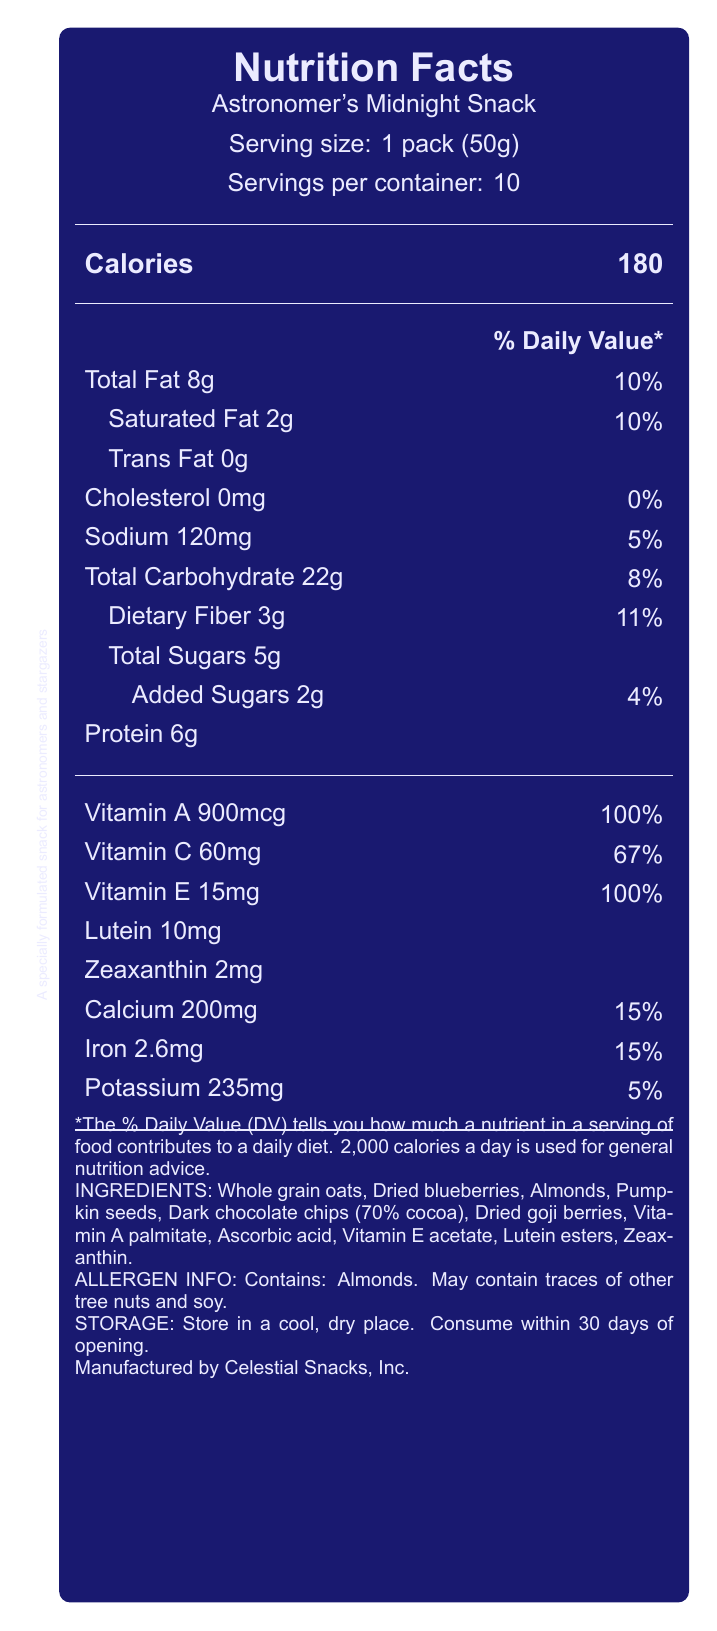What is the serving size of Astronomer's Midnight Snack? The label states that the serving size is "1 pack (50g)".
Answer: 1 pack (50g) How many calories are there in one serving? The label indicates that one serving contains 180 calories.
Answer: 180 What is the total fat content in one serving? The label specifies that the total fat content is 8g per serving.
Answer: 8g How many grams of dietary fiber does one serving contain? The label notes that each serving has 3g of dietary fiber.
Answer: 3g What percentage of the daily value for calcium is provided by one serving? The label shows that one serving supplies 15% of the daily value for calcium.
Answer: 15% Which ingredient is not specified in the list: A. Whole grain oats B. Dried blueberries C. Honey The ingredients listed are Whole grain oats, Dried blueberries, Almonds, Pumpkin seeds, Dark chocolate chips (70% cocoa), Dried goji berries, Vitamin A palmitate, Ascorbic acid, Vitamin E acetate, Lutein esters, and Zeaxanthin. Honey is not mentioned.
Answer: C. Honey How much protein does one serving of Astronomer's Midnight Snack provide? The label confirms that one serving has 6g of protein.
Answer: 6g Does Astronomer's Midnight Snack contain any cholesterol? The label indicates that the cholesterol content is 0mg, meaning it contains no cholesterol.
Answer: No What is the purpose of Astronomer's Midnight Snack as described on the label? This description is explicitly stated towards the bottom of the label.
Answer: A specially formulated snack for astronomers and stargazers, packed with nutrients to support eye health and provide sustained energy during late-night observation sessions. What percentage of the daily value for Vitamin C does one serving provide? The label reveals that one serving offers 67% of the daily value for Vitamin C.
Answer: 67% Which vitamin has the highest daily value percentage in one serving? A. Vitamin A B. Vitamin C C. Vitamin E D. Calcium The label indicates that both Vitamin A and Vitamin E provide 100% of the daily value, but Vitamin A is listed first.
Answer: A. Vitamin A Are there any allergens in Astronomer's Midnight Snack? The label states that it contains almonds, and it may contain traces of other tree nuts and soy.
Answer: Yes What is the total carbohydrate content in one serving? The label states that the total carbohydrate content is 22g per serving.
Answer: 22g How much-added sugar does one serving contain? The label mentions that one serving contains 2g of added sugars.
Answer: 2g Summarize the Nutrition Facts of Astronomer's Midnight Snack. The document contains detailed nutritional information of the snack per serving, its ingredients, allergen information, and storage instructions. It also emphasizes the product's target audience and benefits.
Answer: The Astronomer's Midnight Snack Nutrition Facts label provides details on serving size, calorie content, and various nutrients, including total fat, saturated fat, cholesterol, sodium, total carbohydrates, dietary fiber, total and added sugars, protein, and several vitamins and minerals. The snack is designed specifically for astronomers to support eye health and sustain energy during late-night observations. It contains whole grain oats, dried blueberries, almonds, and other nutritious ingredients, with specific allergens and storage instructions. What is the total vitamin E content per serving, and what percentage of the daily value does it represent? The label indicates that one serving contains 15mg of Vitamin E, which is 100% of the daily value.
Answer: 15mg, 100% What is the amount of trans fat in one serving? The label states that the trans fat content per serving is 0g.
Answer: 0g How much potassium does one serving provide? The label indicates that one serving contains 235mg of potassium.
Answer: 235mg Which is not a mineral listed on the Nutrition Facts: A. Calcium B. Iron C. Magnesium D. Potassium The minerals listed on the label are calcium, iron, and potassium. Magnesium is not mentioned.
Answer: C. Magnesium How many servings are there per container? The label states that there are 10 servings per container.
Answer: 10 What is the main source of dietary fiber in Astronomer's Midnight Snack? The label provides the total amount of dietary fiber but does not specify which ingredient is the primary source of it.
Answer: Cannot be determined 